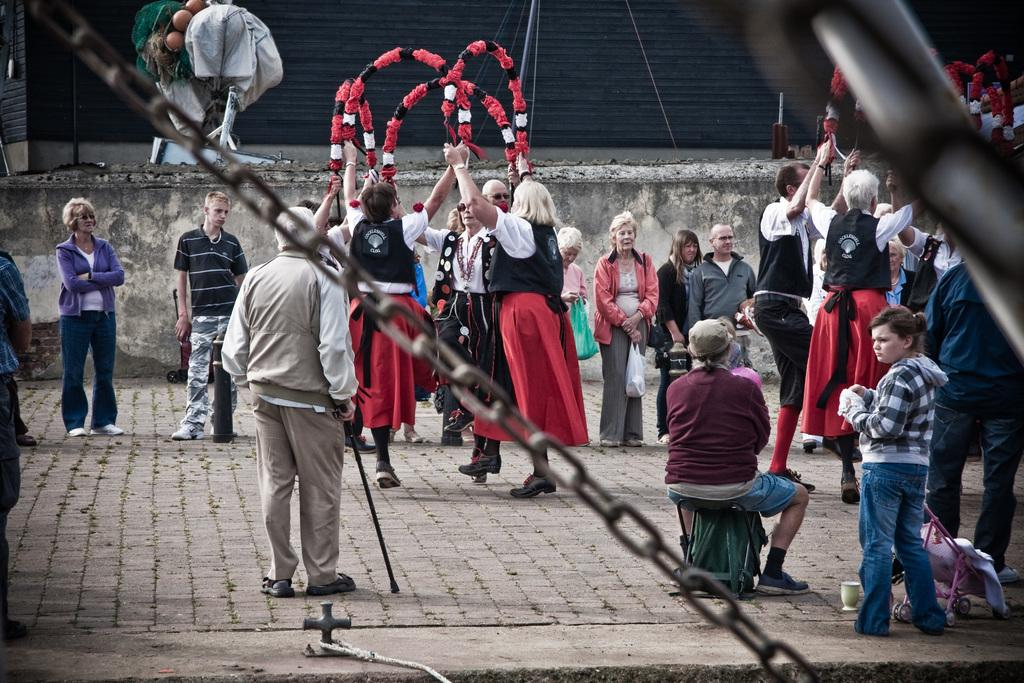How many people are in the image? There are people in the image, but the exact number is not specified. What are the people holding in their hands? The people are holding objects in their hands, but the specific objects are not mentioned. What is the chain used for in the image? The chain's purpose is not specified in the image. What is the shutter associated with in the image? The shutter is present in the image, but its purpose or association is not mentioned. Can you describe any other objects in the image? There are other unspecified objects in the image, but their details are not provided. What type of star can be seen shining brightly in the image? There is no star visible in the image. What kind of fowl is present in the image? There is no mention of any fowl in the image. 